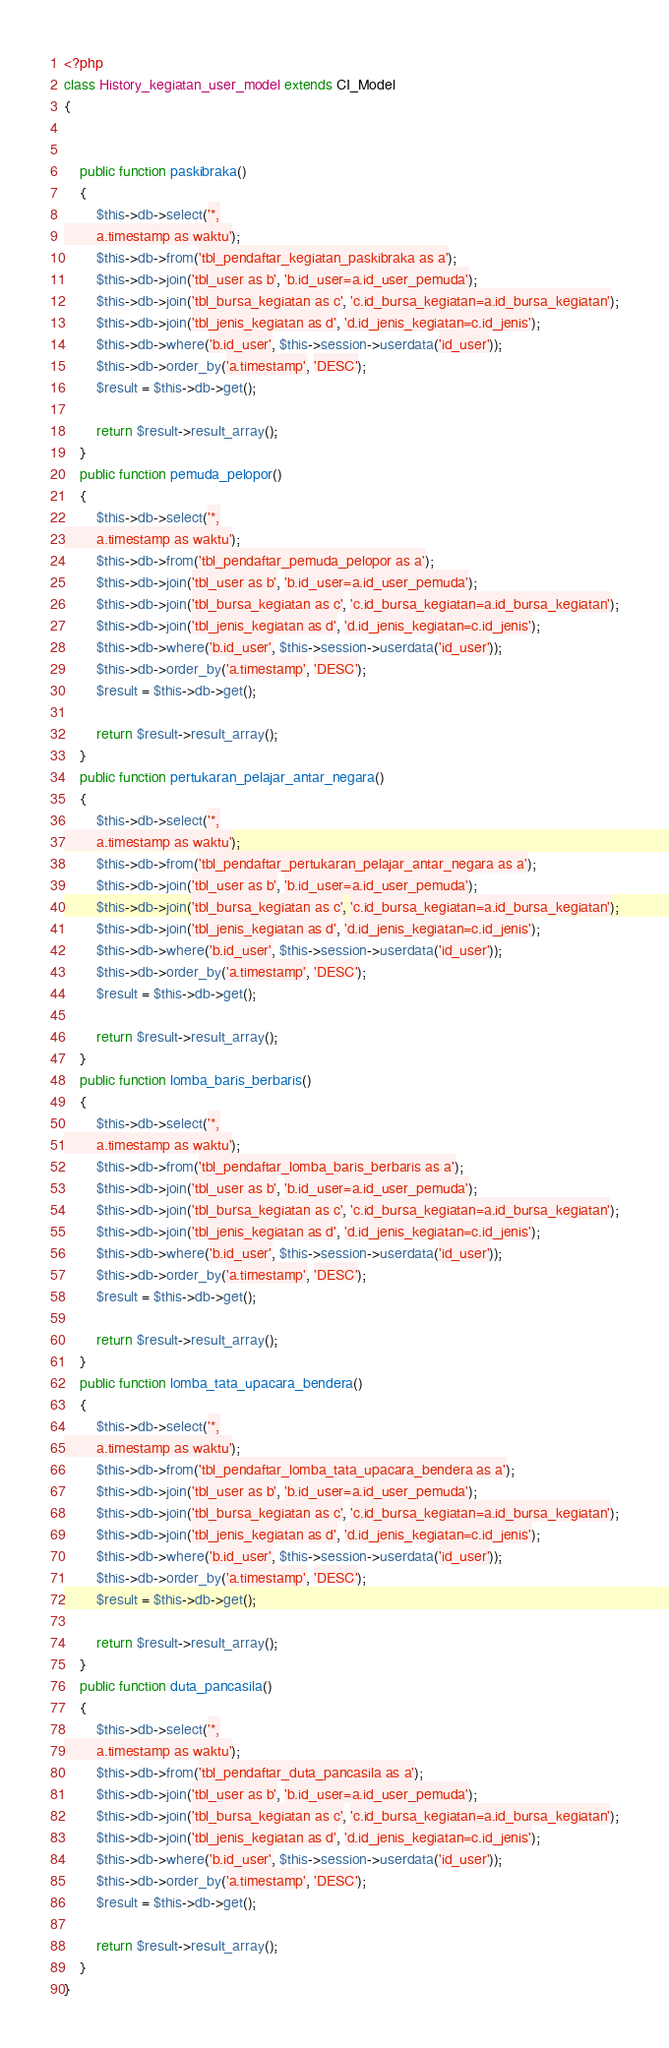<code> <loc_0><loc_0><loc_500><loc_500><_PHP_><?php
class History_kegiatan_user_model extends CI_Model
{


    public function paskibraka()
    {
        $this->db->select('*,
        a.timestamp as waktu');
        $this->db->from('tbl_pendaftar_kegiatan_paskibraka as a');
        $this->db->join('tbl_user as b', 'b.id_user=a.id_user_pemuda');
        $this->db->join('tbl_bursa_kegiatan as c', 'c.id_bursa_kegiatan=a.id_bursa_kegiatan');
        $this->db->join('tbl_jenis_kegiatan as d', 'd.id_jenis_kegiatan=c.id_jenis');
        $this->db->where('b.id_user', $this->session->userdata('id_user'));
        $this->db->order_by('a.timestamp', 'DESC');
        $result = $this->db->get();

        return $result->result_array();
    }
    public function pemuda_pelopor()
    {
        $this->db->select('*,
        a.timestamp as waktu');
        $this->db->from('tbl_pendaftar_pemuda_pelopor as a');
        $this->db->join('tbl_user as b', 'b.id_user=a.id_user_pemuda');
        $this->db->join('tbl_bursa_kegiatan as c', 'c.id_bursa_kegiatan=a.id_bursa_kegiatan');
        $this->db->join('tbl_jenis_kegiatan as d', 'd.id_jenis_kegiatan=c.id_jenis');
        $this->db->where('b.id_user', $this->session->userdata('id_user'));
        $this->db->order_by('a.timestamp', 'DESC');
        $result = $this->db->get();

        return $result->result_array();
    }
    public function pertukaran_pelajar_antar_negara()
    {
        $this->db->select('*,
        a.timestamp as waktu');
        $this->db->from('tbl_pendaftar_pertukaran_pelajar_antar_negara as a');
        $this->db->join('tbl_user as b', 'b.id_user=a.id_user_pemuda');
        $this->db->join('tbl_bursa_kegiatan as c', 'c.id_bursa_kegiatan=a.id_bursa_kegiatan');
        $this->db->join('tbl_jenis_kegiatan as d', 'd.id_jenis_kegiatan=c.id_jenis');
        $this->db->where('b.id_user', $this->session->userdata('id_user'));
        $this->db->order_by('a.timestamp', 'DESC');
        $result = $this->db->get();

        return $result->result_array();
    }
    public function lomba_baris_berbaris()
    {
        $this->db->select('*,
        a.timestamp as waktu');
        $this->db->from('tbl_pendaftar_lomba_baris_berbaris as a');
        $this->db->join('tbl_user as b', 'b.id_user=a.id_user_pemuda');
        $this->db->join('tbl_bursa_kegiatan as c', 'c.id_bursa_kegiatan=a.id_bursa_kegiatan');
        $this->db->join('tbl_jenis_kegiatan as d', 'd.id_jenis_kegiatan=c.id_jenis');
        $this->db->where('b.id_user', $this->session->userdata('id_user'));
        $this->db->order_by('a.timestamp', 'DESC');
        $result = $this->db->get();

        return $result->result_array();
    }
    public function lomba_tata_upacara_bendera()
    {
        $this->db->select('*,
        a.timestamp as waktu');
        $this->db->from('tbl_pendaftar_lomba_tata_upacara_bendera as a');
        $this->db->join('tbl_user as b', 'b.id_user=a.id_user_pemuda');
        $this->db->join('tbl_bursa_kegiatan as c', 'c.id_bursa_kegiatan=a.id_bursa_kegiatan');
        $this->db->join('tbl_jenis_kegiatan as d', 'd.id_jenis_kegiatan=c.id_jenis');
        $this->db->where('b.id_user', $this->session->userdata('id_user'));
        $this->db->order_by('a.timestamp', 'DESC');
        $result = $this->db->get();

        return $result->result_array();
    }
    public function duta_pancasila()
    {
        $this->db->select('*,
        a.timestamp as waktu');
        $this->db->from('tbl_pendaftar_duta_pancasila as a');
        $this->db->join('tbl_user as b', 'b.id_user=a.id_user_pemuda');
        $this->db->join('tbl_bursa_kegiatan as c', 'c.id_bursa_kegiatan=a.id_bursa_kegiatan');
        $this->db->join('tbl_jenis_kegiatan as d', 'd.id_jenis_kegiatan=c.id_jenis');
        $this->db->where('b.id_user', $this->session->userdata('id_user'));
        $this->db->order_by('a.timestamp', 'DESC');
        $result = $this->db->get();

        return $result->result_array();
    }
}
</code> 